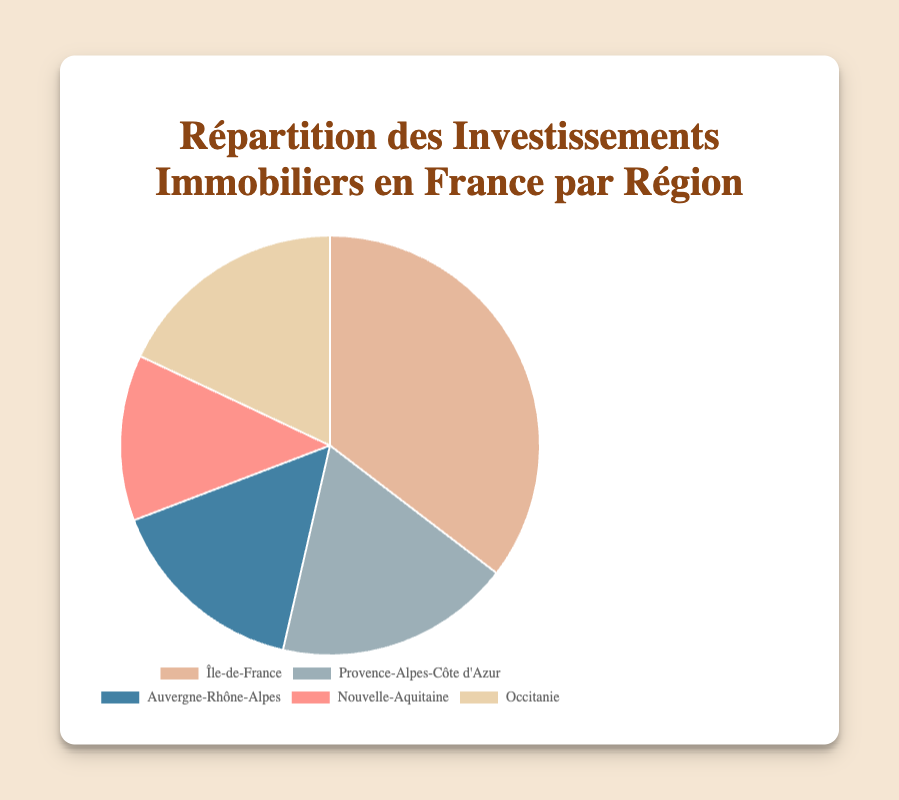Which region has the highest percentage share of real estate investments? By looking at the chart, the region with the largest section in the pie chart represents the highest percentage. Île-de-France has the largest section.
Answer: Île-de-France What is the combined percentage share of Provence-Alpes-Côte d'Azur and Occitanie? Add the percentages of Provence-Alpes-Côte d'Azur (18.2%) and Occitanie (18.0%). Therefore, 18.2 + 18.0 = 36.2%.
Answer: 36.2% Which regions have nearly identical percentage shares? By visually inspecting the pie chart, both Provence-Alpes-Côte d'Azur and Occitanie have similar sizes. The data shows Provence-Alpes-Côte d'Azur has 18.2% and Occitanie has 18.0%, which are nearly identical.
Answer: Provence-Alpes-Côte d'Azur and Occitanie What is the percentage difference between the region with the highest investment and the region with the lowest? The highest is Île-de-France with 35.4%, and the lowest is Nouvelle-Aquitaine with 12.8%. The difference is 35.4 - 12.8 = 22.6%.
Answer: 22.6% Which region's segment is represented by the color closest to blue? By identifying visual colors, the segment closest to blue represents the Auvergne-Rhône-Alpes region.
Answer: Auvergne-Rhône-Alpes What percentage of French real estate investments are shared by regions below 20%? Regions below 20% are Provence-Alpes-Côte d'Azur (18.2%), Auvergne-Rhône-Alpes (15.6%), Nouvelle-Aquitaine (12.8%), and Occitanie (18.0%). Adding these values: 18.2 + 15.6 + 12.8 + 18.0 = 64.6%.
Answer: 64.6% How much greater is Île-de-France's percentage share compared to Auvergne-Rhône-Alpes? The percentage for Île-de-France is 35.4%, and for Auvergne-Rhône-Alpes it is 15.6%. The difference is 35.4 - 15.6 = 19.8%.
Answer: 19.8% If an investor is looking to invest evenly between the top three regions, what percentage of total investments would that be? The top three regions are Île-de-France (35.4%), Provence-Alpes-Côte d'Azur (18.2%), and Occitanie (18.0%). Their combined percentage is 35.4 + 18.2 + 18.0 = 71.6%.
Answer: 71.6% 